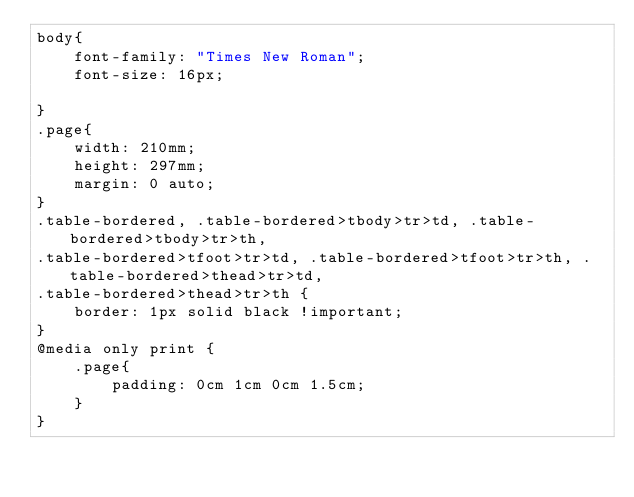Convert code to text. <code><loc_0><loc_0><loc_500><loc_500><_CSS_>body{
	font-family: "Times New Roman";
	font-size: 16px;

}
.page{
	width: 210mm;
	height: 297mm;
	margin: 0 auto;
}
.table-bordered, .table-bordered>tbody>tr>td, .table-bordered>tbody>tr>th, 
.table-bordered>tfoot>tr>td, .table-bordered>tfoot>tr>th, .table-bordered>thead>tr>td, 
.table-bordered>thead>tr>th {
	border: 1px solid black !important;
}
@media only print {
	.page{
		padding: 0cm 1cm 0cm 1.5cm;
	}	
}
</code> 